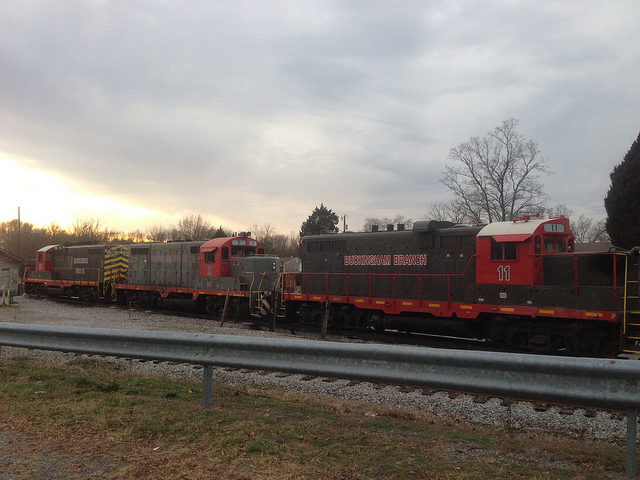<image>What letters are on the train? I am not sure about the letters on the train. It could be 'birmingham branch' or 'buckingham branch'. Which direction is the bottom train heading? It is ambiguous to determine the direction the bottom train is heading since some answers are saying 'right' and others 'north'. What is powering the train? It is ambiguous what is powering the train, it could be electricity, coal, fuel, or diesel. Which direction is the bottom train heading? It is ambiguous which direction the bottom train is heading. It can be seen going north or right. What letters are on the train? I am not sure what letters are on the train. It can be seen as 'birmingham branch', 'buckingham branch', 'english', or 'unclear'. What is powering the train? It is not clear what is powering the train. It can be powered by electricity, coal, fuel, engine or diesel fuel. 